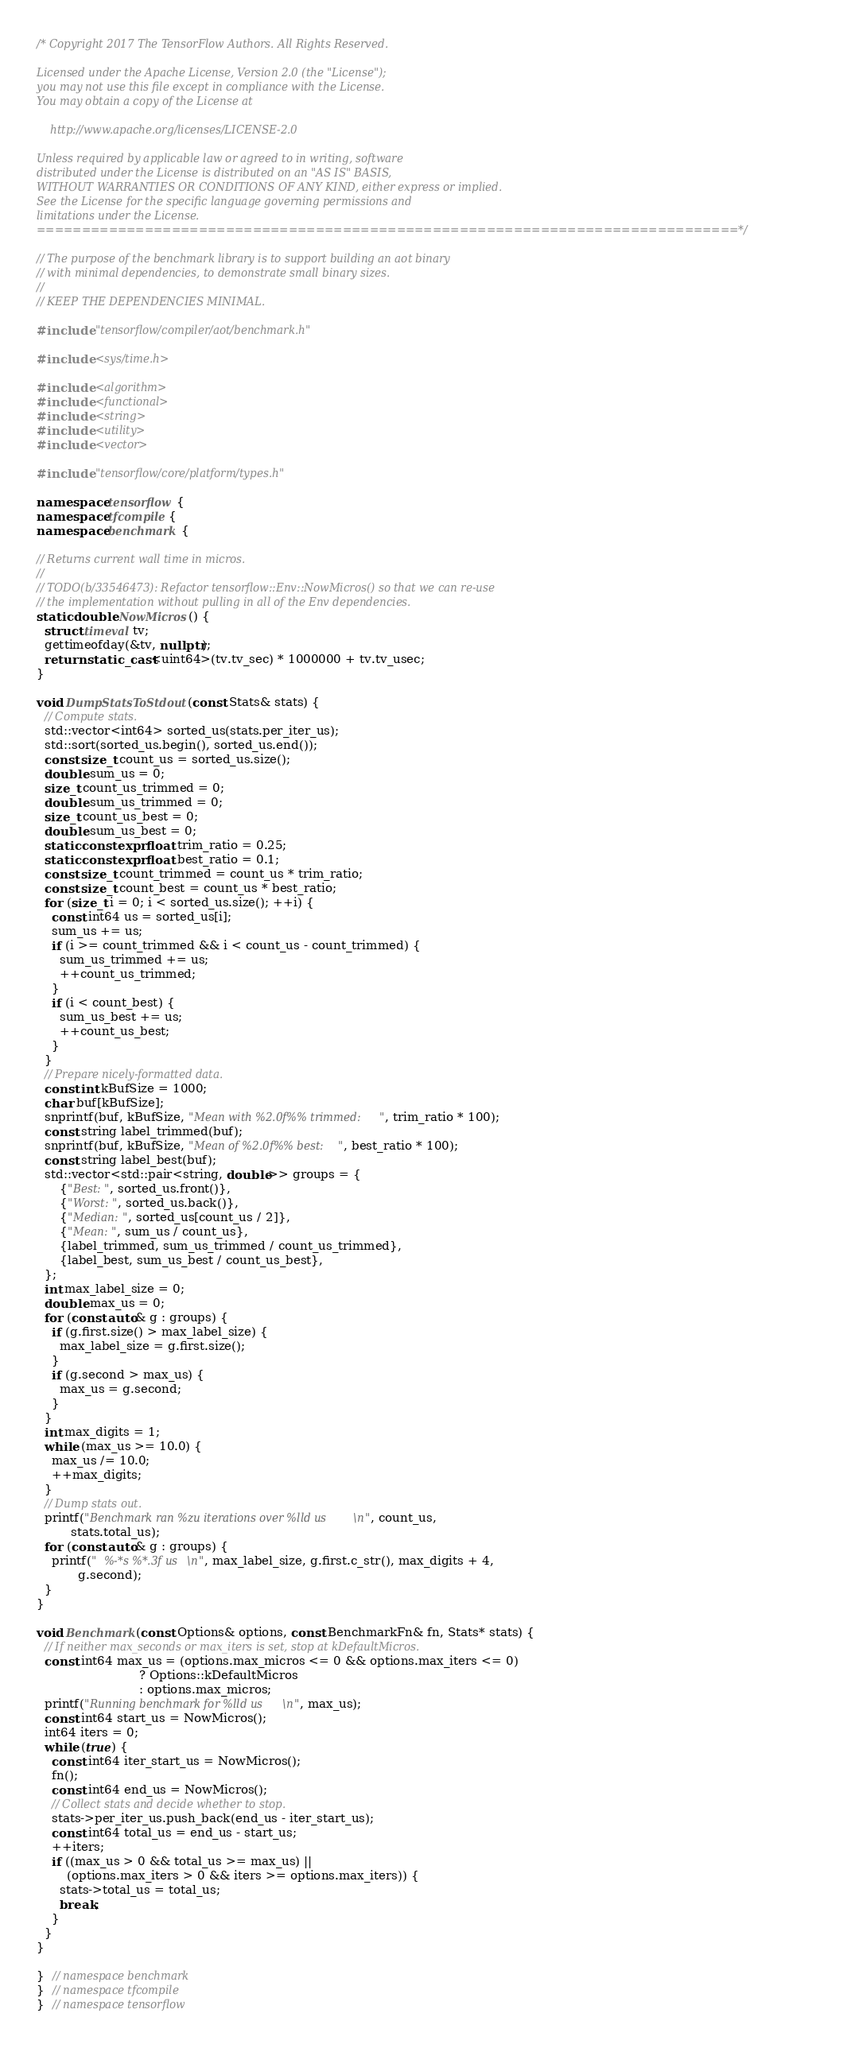Convert code to text. <code><loc_0><loc_0><loc_500><loc_500><_C++_>/* Copyright 2017 The TensorFlow Authors. All Rights Reserved.

Licensed under the Apache License, Version 2.0 (the "License");
you may not use this file except in compliance with the License.
You may obtain a copy of the License at

    http://www.apache.org/licenses/LICENSE-2.0

Unless required by applicable law or agreed to in writing, software
distributed under the License is distributed on an "AS IS" BASIS,
WITHOUT WARRANTIES OR CONDITIONS OF ANY KIND, either express or implied.
See the License for the specific language governing permissions and
limitations under the License.
==============================================================================*/

// The purpose of the benchmark library is to support building an aot binary
// with minimal dependencies, to demonstrate small binary sizes.
//
// KEEP THE DEPENDENCIES MINIMAL.

#include "tensorflow/compiler/aot/benchmark.h"

#include <sys/time.h>

#include <algorithm>
#include <functional>
#include <string>
#include <utility>
#include <vector>

#include "tensorflow/core/platform/types.h"

namespace tensorflow {
namespace tfcompile {
namespace benchmark {

// Returns current wall time in micros.
//
// TODO(b/33546473): Refactor tensorflow::Env::NowMicros() so that we can re-use
// the implementation without pulling in all of the Env dependencies.
static double NowMicros() {
  struct timeval tv;
  gettimeofday(&tv, nullptr);
  return static_cast<uint64>(tv.tv_sec) * 1000000 + tv.tv_usec;
}

void DumpStatsToStdout(const Stats& stats) {
  // Compute stats.
  std::vector<int64> sorted_us(stats.per_iter_us);
  std::sort(sorted_us.begin(), sorted_us.end());
  const size_t count_us = sorted_us.size();
  double sum_us = 0;
  size_t count_us_trimmed = 0;
  double sum_us_trimmed = 0;
  size_t count_us_best = 0;
  double sum_us_best = 0;
  static constexpr float trim_ratio = 0.25;
  static constexpr float best_ratio = 0.1;
  const size_t count_trimmed = count_us * trim_ratio;
  const size_t count_best = count_us * best_ratio;
  for (size_t i = 0; i < sorted_us.size(); ++i) {
    const int64 us = sorted_us[i];
    sum_us += us;
    if (i >= count_trimmed && i < count_us - count_trimmed) {
      sum_us_trimmed += us;
      ++count_us_trimmed;
    }
    if (i < count_best) {
      sum_us_best += us;
      ++count_us_best;
    }
  }
  // Prepare nicely-formatted data.
  const int kBufSize = 1000;
  char buf[kBufSize];
  snprintf(buf, kBufSize, "Mean with %2.0f%% trimmed:", trim_ratio * 100);
  const string label_trimmed(buf);
  snprintf(buf, kBufSize, "Mean of %2.0f%% best:", best_ratio * 100);
  const string label_best(buf);
  std::vector<std::pair<string, double>> groups = {
      {"Best:", sorted_us.front()},
      {"Worst:", sorted_us.back()},
      {"Median:", sorted_us[count_us / 2]},
      {"Mean:", sum_us / count_us},
      {label_trimmed, sum_us_trimmed / count_us_trimmed},
      {label_best, sum_us_best / count_us_best},
  };
  int max_label_size = 0;
  double max_us = 0;
  for (const auto& g : groups) {
    if (g.first.size() > max_label_size) {
      max_label_size = g.first.size();
    }
    if (g.second > max_us) {
      max_us = g.second;
    }
  }
  int max_digits = 1;
  while (max_us >= 10.0) {
    max_us /= 10.0;
    ++max_digits;
  }
  // Dump stats out.
  printf("Benchmark ran %zu iterations over %lld us\n", count_us,
         stats.total_us);
  for (const auto& g : groups) {
    printf("  %-*s %*.3f us\n", max_label_size, g.first.c_str(), max_digits + 4,
           g.second);
  }
}

void Benchmark(const Options& options, const BenchmarkFn& fn, Stats* stats) {
  // If neither max_seconds or max_iters is set, stop at kDefaultMicros.
  const int64 max_us = (options.max_micros <= 0 && options.max_iters <= 0)
                           ? Options::kDefaultMicros
                           : options.max_micros;
  printf("Running benchmark for %lld us\n", max_us);
  const int64 start_us = NowMicros();
  int64 iters = 0;
  while (true) {
    const int64 iter_start_us = NowMicros();
    fn();
    const int64 end_us = NowMicros();
    // Collect stats and decide whether to stop.
    stats->per_iter_us.push_back(end_us - iter_start_us);
    const int64 total_us = end_us - start_us;
    ++iters;
    if ((max_us > 0 && total_us >= max_us) ||
        (options.max_iters > 0 && iters >= options.max_iters)) {
      stats->total_us = total_us;
      break;
    }
  }
}

}  // namespace benchmark
}  // namespace tfcompile
}  // namespace tensorflow
</code> 